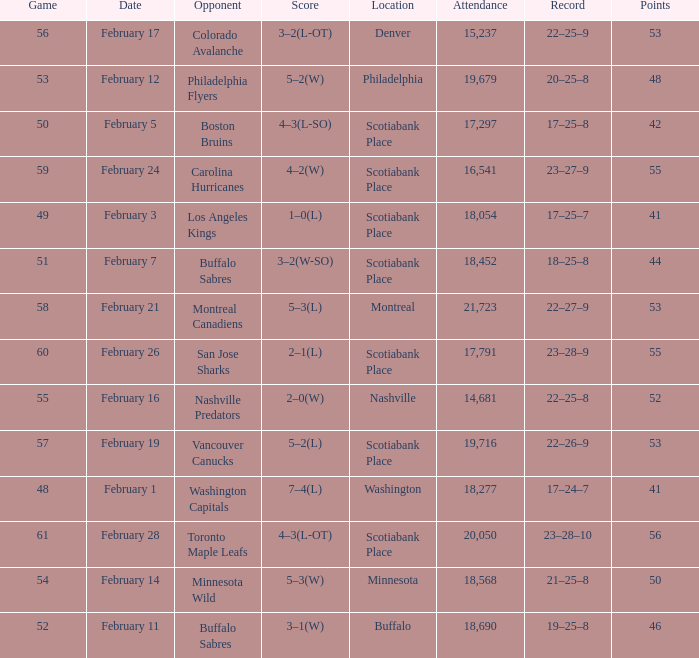What average game was held on february 24 and has an attendance smaller than 16,541? None. 